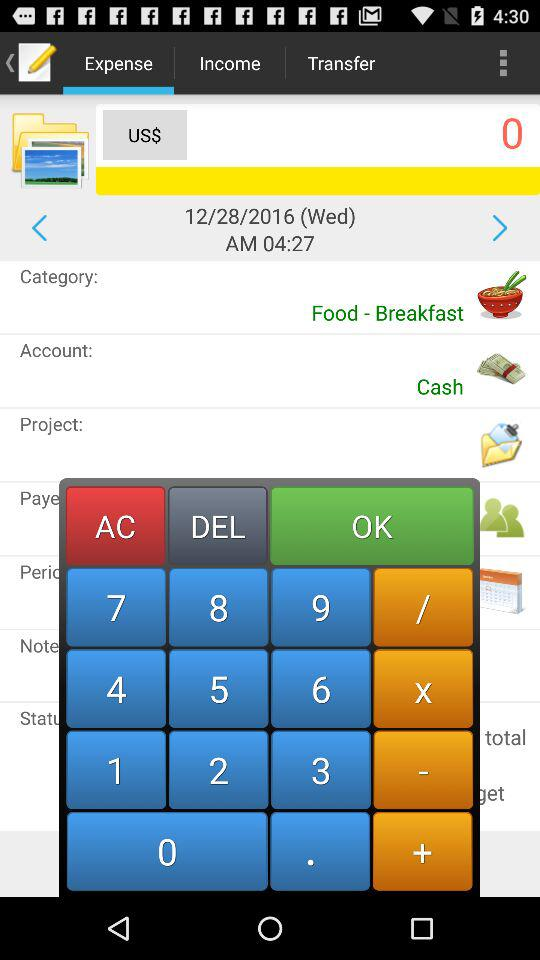What is the given date? The given date is 12/28/2016. 